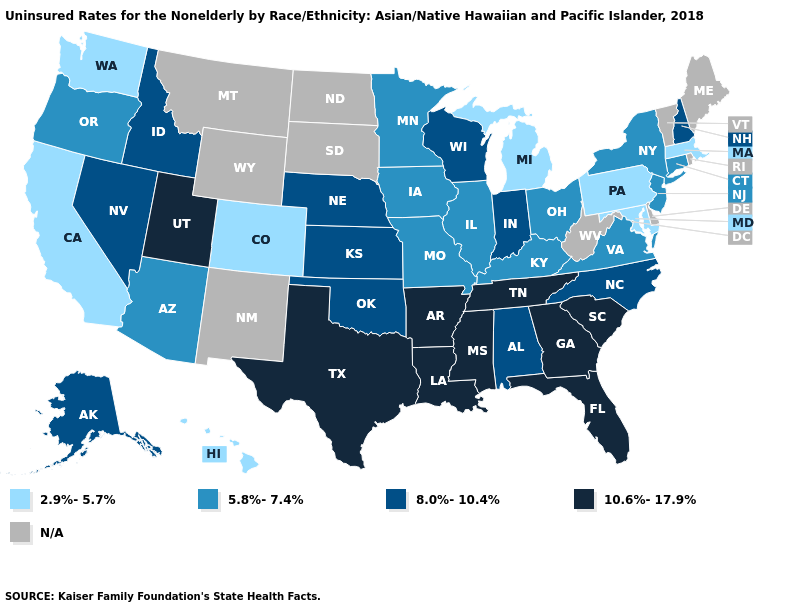Name the states that have a value in the range 2.9%-5.7%?
Write a very short answer. California, Colorado, Hawaii, Maryland, Massachusetts, Michigan, Pennsylvania, Washington. Does the first symbol in the legend represent the smallest category?
Be succinct. Yes. What is the value of Louisiana?
Be succinct. 10.6%-17.9%. Name the states that have a value in the range 8.0%-10.4%?
Write a very short answer. Alabama, Alaska, Idaho, Indiana, Kansas, Nebraska, Nevada, New Hampshire, North Carolina, Oklahoma, Wisconsin. Does Massachusetts have the lowest value in the Northeast?
Short answer required. Yes. Name the states that have a value in the range N/A?
Short answer required. Delaware, Maine, Montana, New Mexico, North Dakota, Rhode Island, South Dakota, Vermont, West Virginia, Wyoming. How many symbols are there in the legend?
Be succinct. 5. What is the value of Iowa?
Quick response, please. 5.8%-7.4%. What is the value of Wisconsin?
Concise answer only. 8.0%-10.4%. Name the states that have a value in the range 5.8%-7.4%?
Be succinct. Arizona, Connecticut, Illinois, Iowa, Kentucky, Minnesota, Missouri, New Jersey, New York, Ohio, Oregon, Virginia. Name the states that have a value in the range N/A?
Give a very brief answer. Delaware, Maine, Montana, New Mexico, North Dakota, Rhode Island, South Dakota, Vermont, West Virginia, Wyoming. Name the states that have a value in the range 2.9%-5.7%?
Keep it brief. California, Colorado, Hawaii, Maryland, Massachusetts, Michigan, Pennsylvania, Washington. Name the states that have a value in the range N/A?
Quick response, please. Delaware, Maine, Montana, New Mexico, North Dakota, Rhode Island, South Dakota, Vermont, West Virginia, Wyoming. 